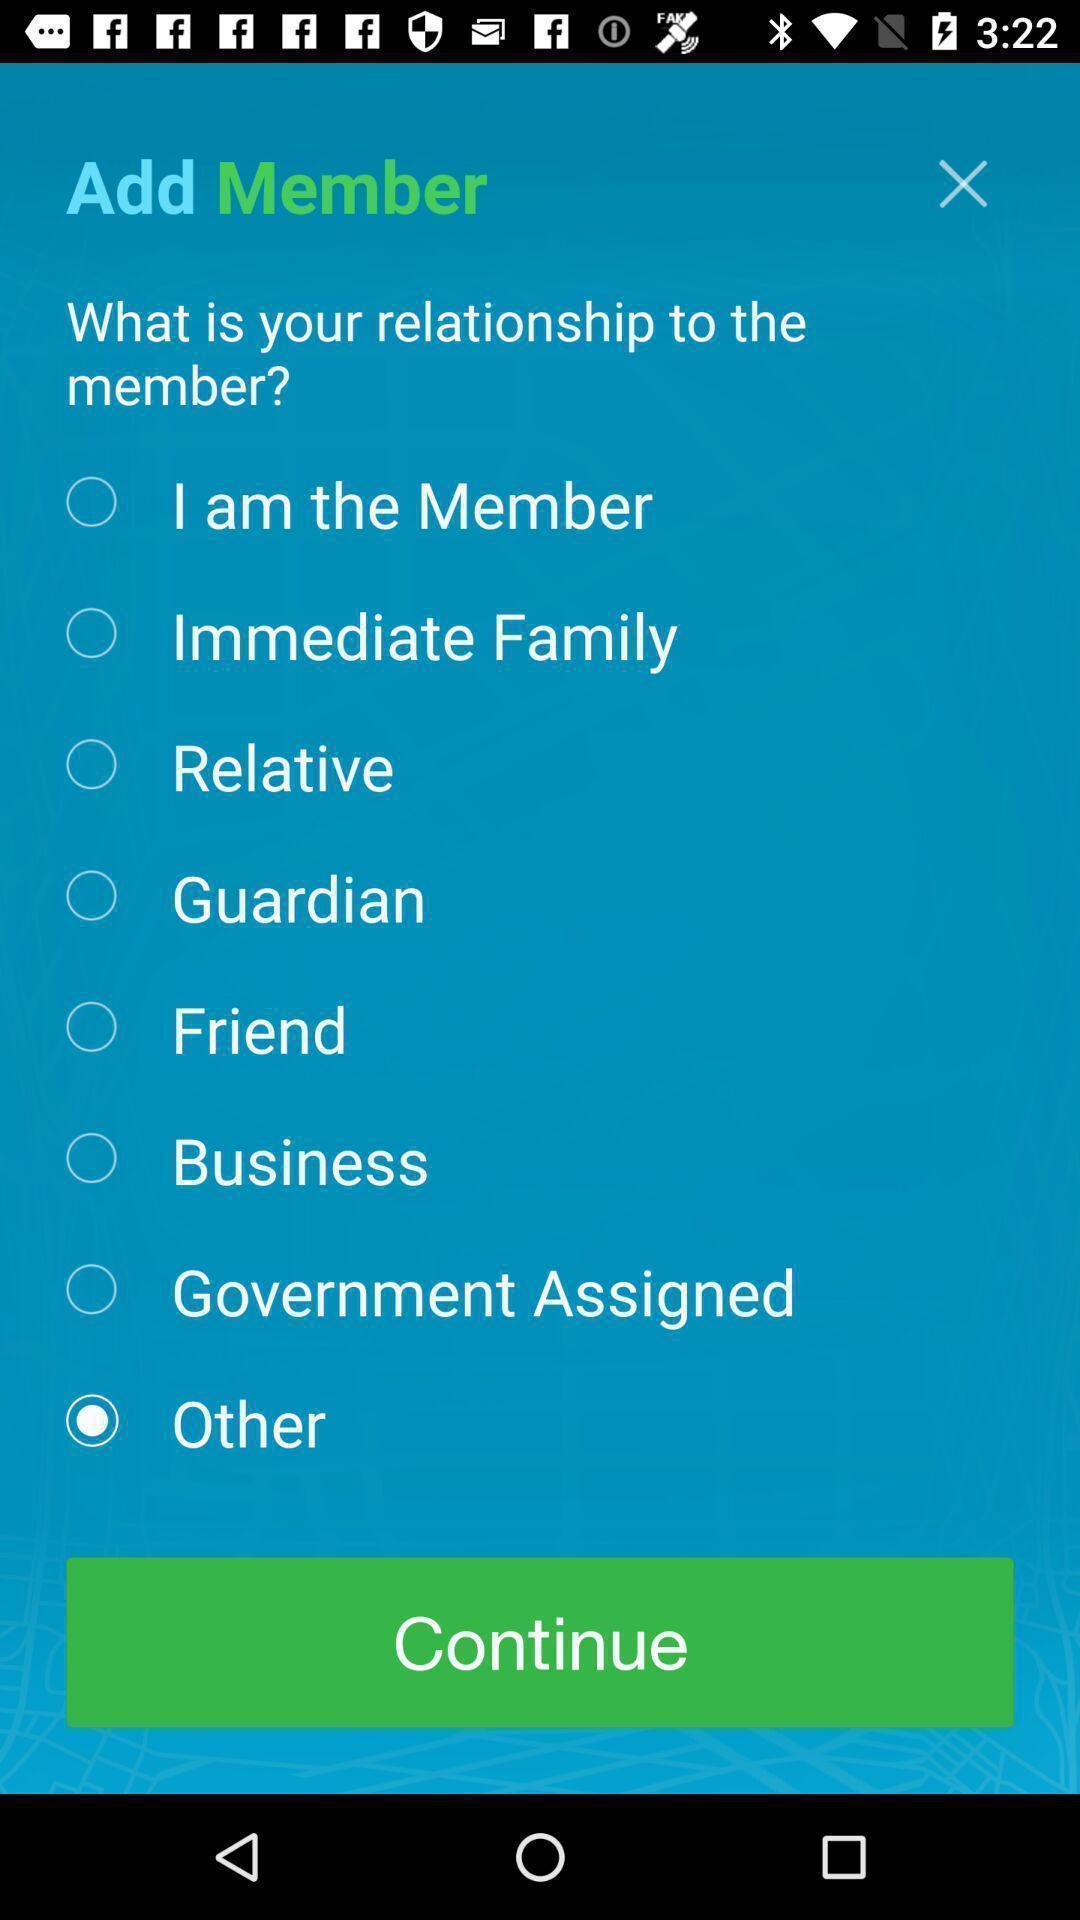What is the overall content of this screenshot? Page displaying various options to select. 